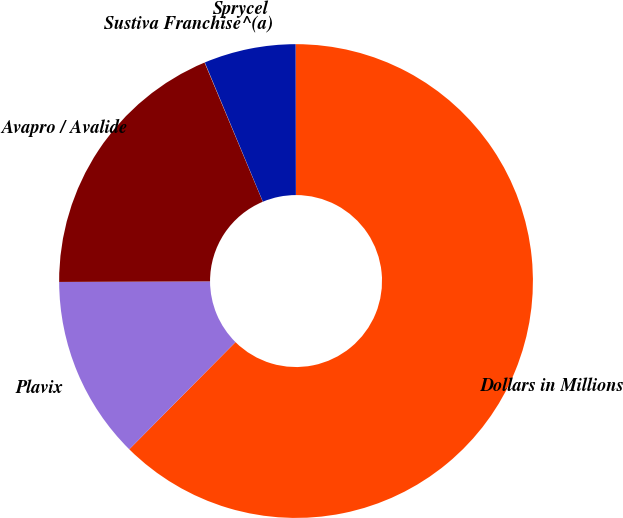<chart> <loc_0><loc_0><loc_500><loc_500><pie_chart><fcel>Dollars in Millions<fcel>Plavix<fcel>Avapro / Avalide<fcel>Sustiva Franchise^(a)<fcel>Sprycel<nl><fcel>62.46%<fcel>12.51%<fcel>18.75%<fcel>0.02%<fcel>6.26%<nl></chart> 